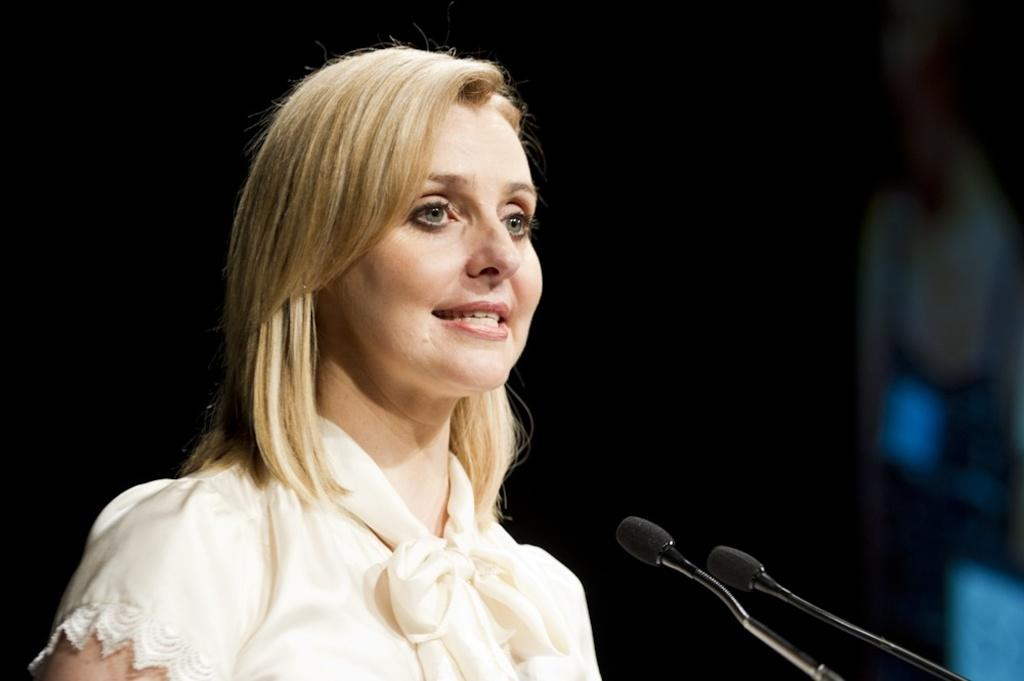Who is the main subject in the image? There is a woman in the image. Where is the woman positioned in the image? The woman is standing on the left side. What is the woman wearing in the image? The woman is wearing a white dress. What object can be seen at the bottom right side of the image? There is a microphone (Mic) at the bottom right side of the image. How many ladybugs are crawling on the woman's dress in the image? There are no ladybugs present on the woman's dress in the image. Is there any smoke visible in the image? There is no smoke visible in the image. 